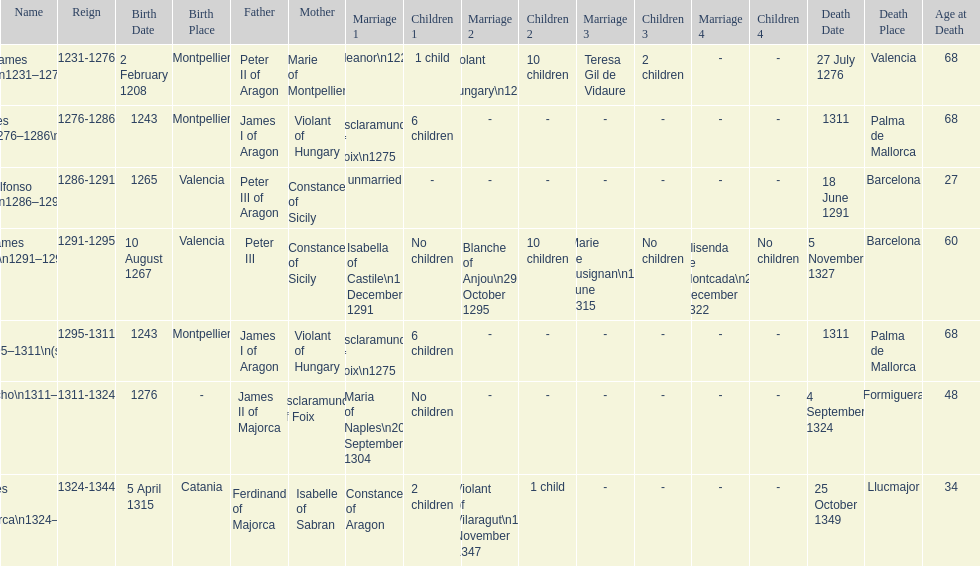How long was james ii in power, including his second rule? 26 years. 